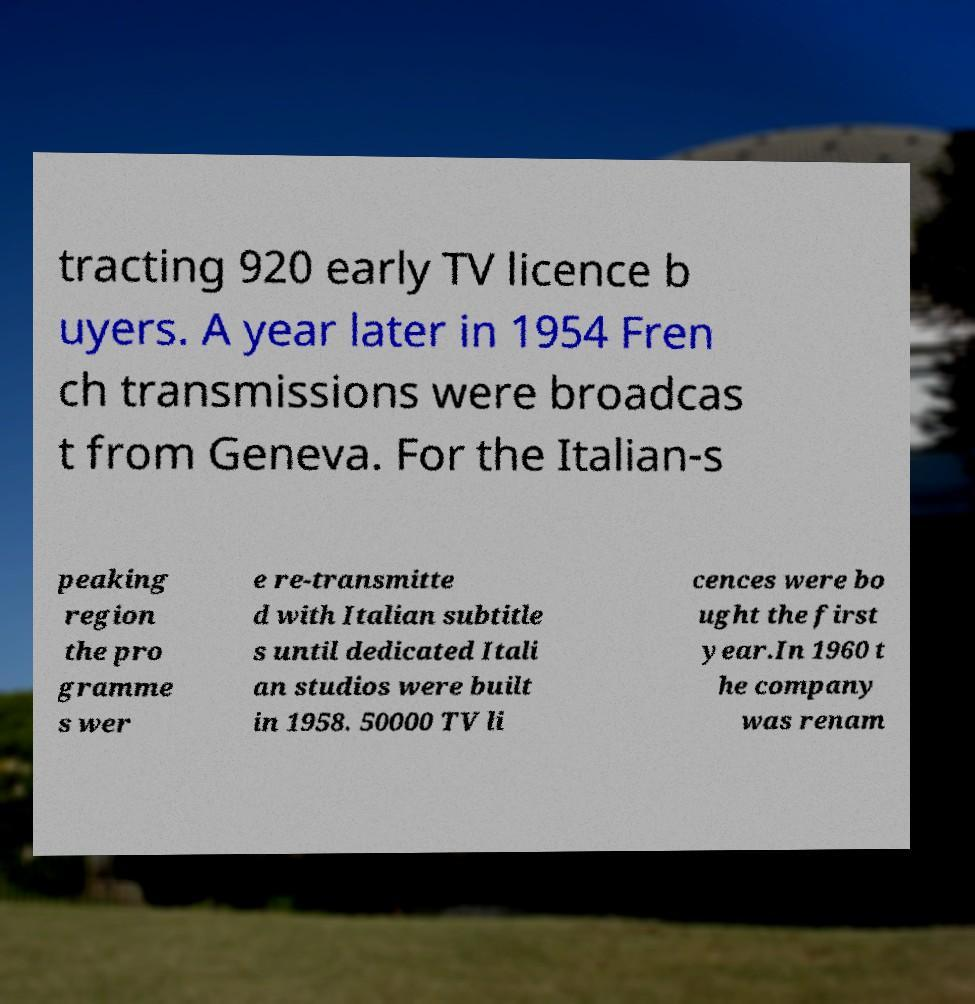Can you read and provide the text displayed in the image?This photo seems to have some interesting text. Can you extract and type it out for me? tracting 920 early TV licence b uyers. A year later in 1954 Fren ch transmissions were broadcas t from Geneva. For the Italian-s peaking region the pro gramme s wer e re-transmitte d with Italian subtitle s until dedicated Itali an studios were built in 1958. 50000 TV li cences were bo ught the first year.In 1960 t he company was renam 